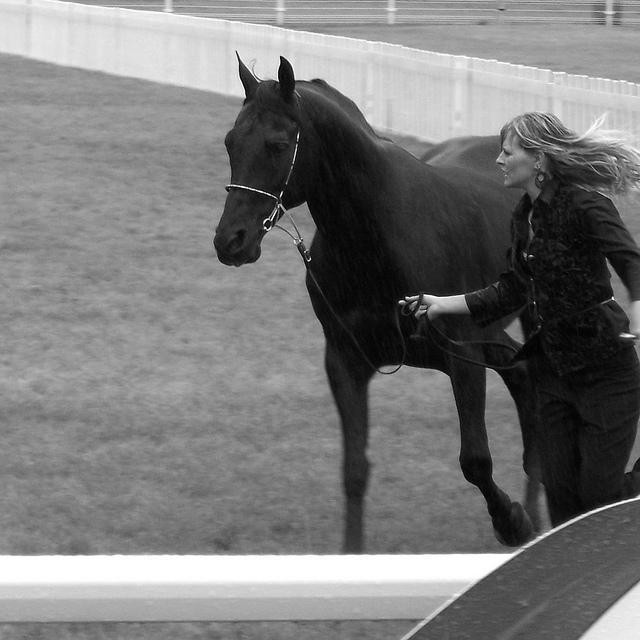How many horses?
Give a very brief answer. 1. 